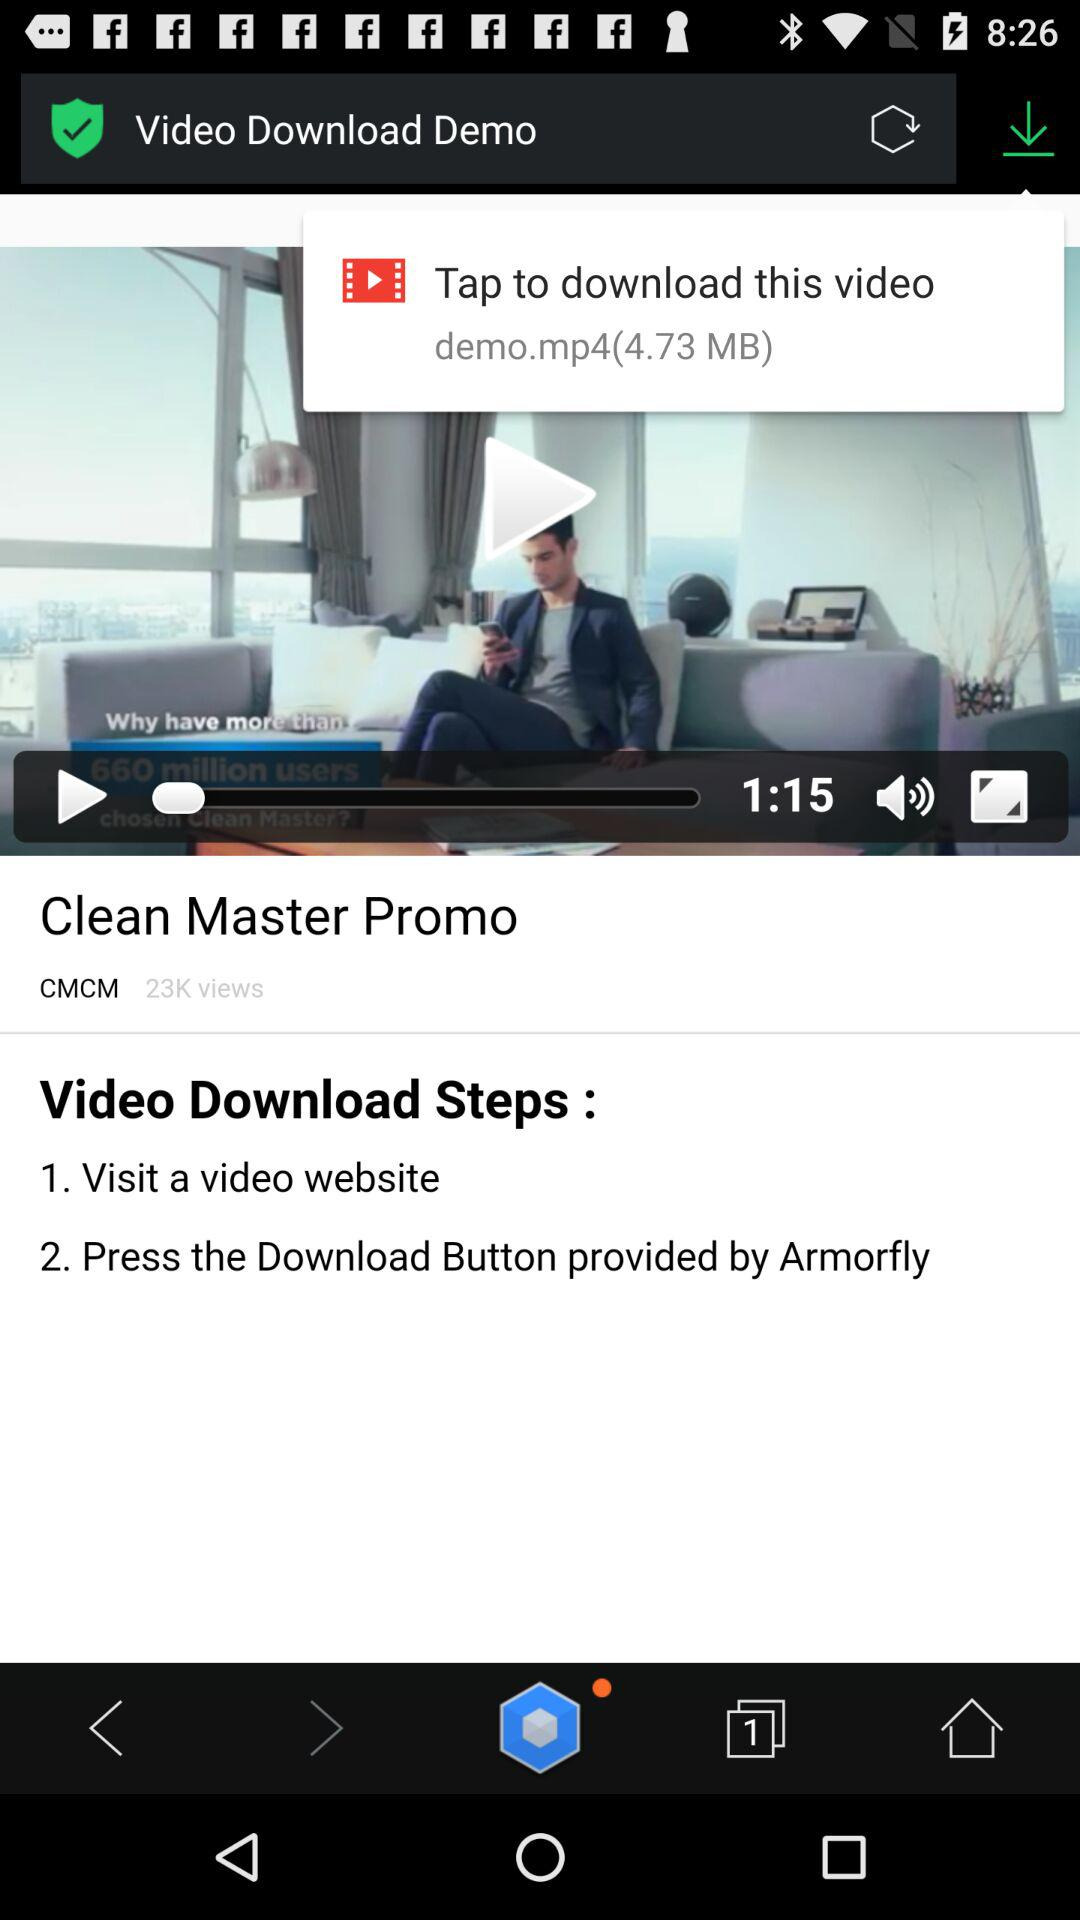How many video download steps are there?
Answer the question using a single word or phrase. 2 